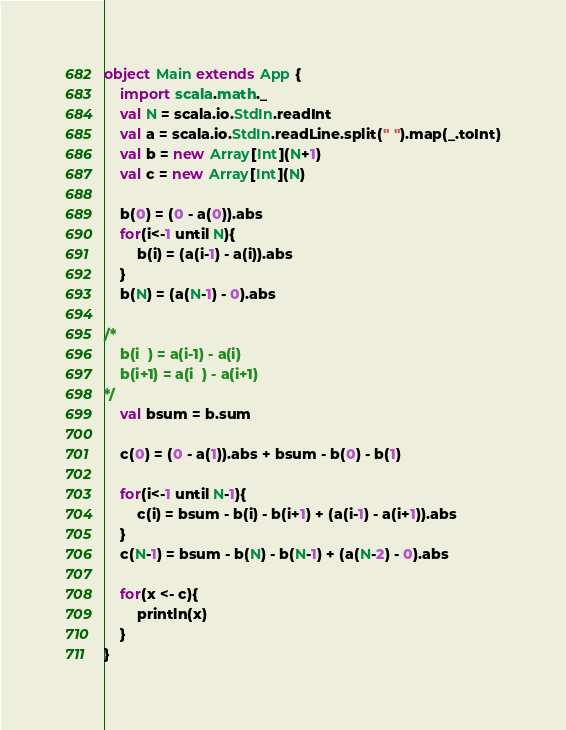Convert code to text. <code><loc_0><loc_0><loc_500><loc_500><_Scala_>object Main extends App {
	import scala.math._
	val N = scala.io.StdIn.readInt
	val a = scala.io.StdIn.readLine.split(" ").map(_.toInt)
	val b = new Array[Int](N+1)
	val c = new Array[Int](N)
	
	b(0) = (0 - a(0)).abs
	for(i<-1 until N){
		b(i) = (a(i-1) - a(i)).abs
	}
	b(N) = (a(N-1) - 0).abs

/*
	b(i  ) = a(i-1) - a(i)
	b(i+1) = a(i  ) - a(i+1)
*/
	val bsum = b.sum

	c(0) = (0 - a(1)).abs + bsum - b(0) - b(1)

	for(i<-1 until N-1){
		c(i) = bsum - b(i) - b(i+1) + (a(i-1) - a(i+1)).abs
	}
	c(N-1) = bsum - b(N) - b(N-1) + (a(N-2) - 0).abs

	for(x <- c){
		println(x)
	}
}
</code> 